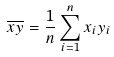Convert formula to latex. <formula><loc_0><loc_0><loc_500><loc_500>\overline { x y } = \frac { 1 } { n } \sum _ { i = 1 } ^ { n } x _ { i } y _ { i }</formula> 